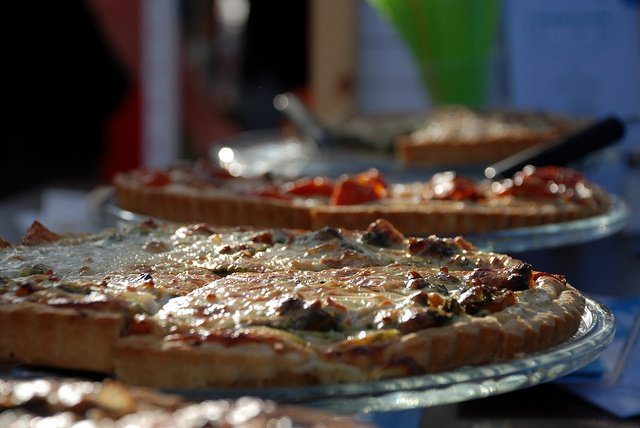Describe the objects in this image and their specific colors. I can see pizza in black, maroon, and gray tones, pizza in black, maroon, and gray tones, pizza in black, maroon, and gray tones, pizza in black, lightgray, darkgray, and gray tones, and knife in black, gray, navy, and darkblue tones in this image. 